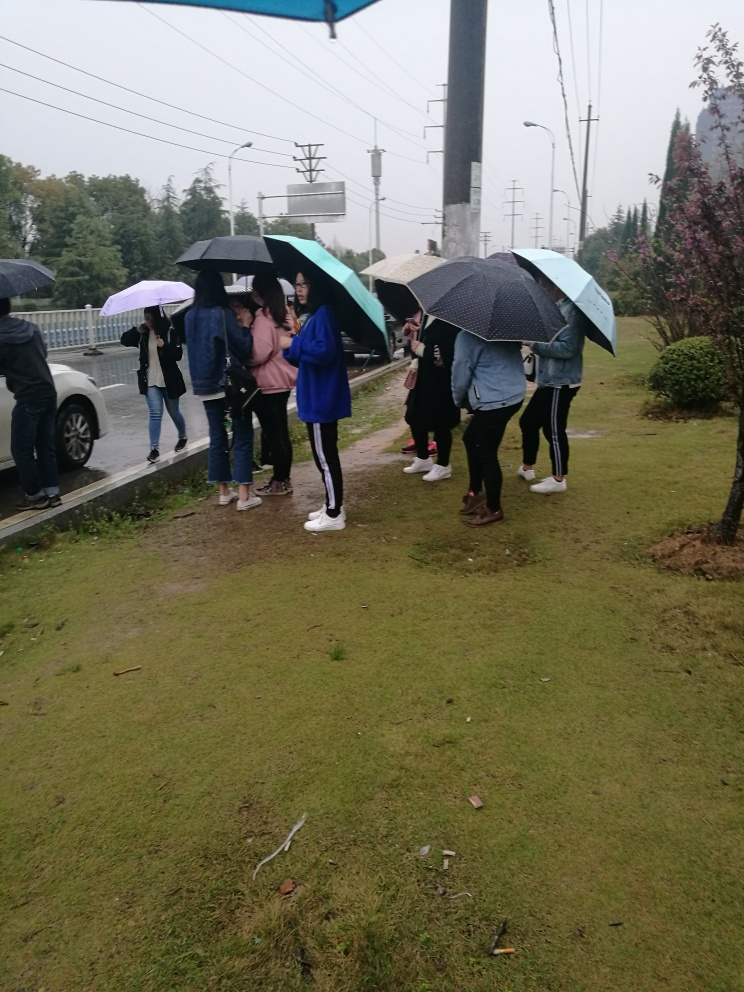How clear is the passerby holding an umbrella? The passerby holding an umbrella has a certain level of clarity, but details such as facial features or expressions are not easily distinguishable. Therefore, the clarity can be best described as decent, considering the distance and possibly the weather conditions. 